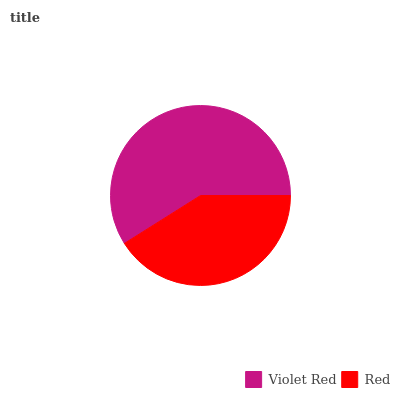Is Red the minimum?
Answer yes or no. Yes. Is Violet Red the maximum?
Answer yes or no. Yes. Is Red the maximum?
Answer yes or no. No. Is Violet Red greater than Red?
Answer yes or no. Yes. Is Red less than Violet Red?
Answer yes or no. Yes. Is Red greater than Violet Red?
Answer yes or no. No. Is Violet Red less than Red?
Answer yes or no. No. Is Violet Red the high median?
Answer yes or no. Yes. Is Red the low median?
Answer yes or no. Yes. Is Red the high median?
Answer yes or no. No. Is Violet Red the low median?
Answer yes or no. No. 